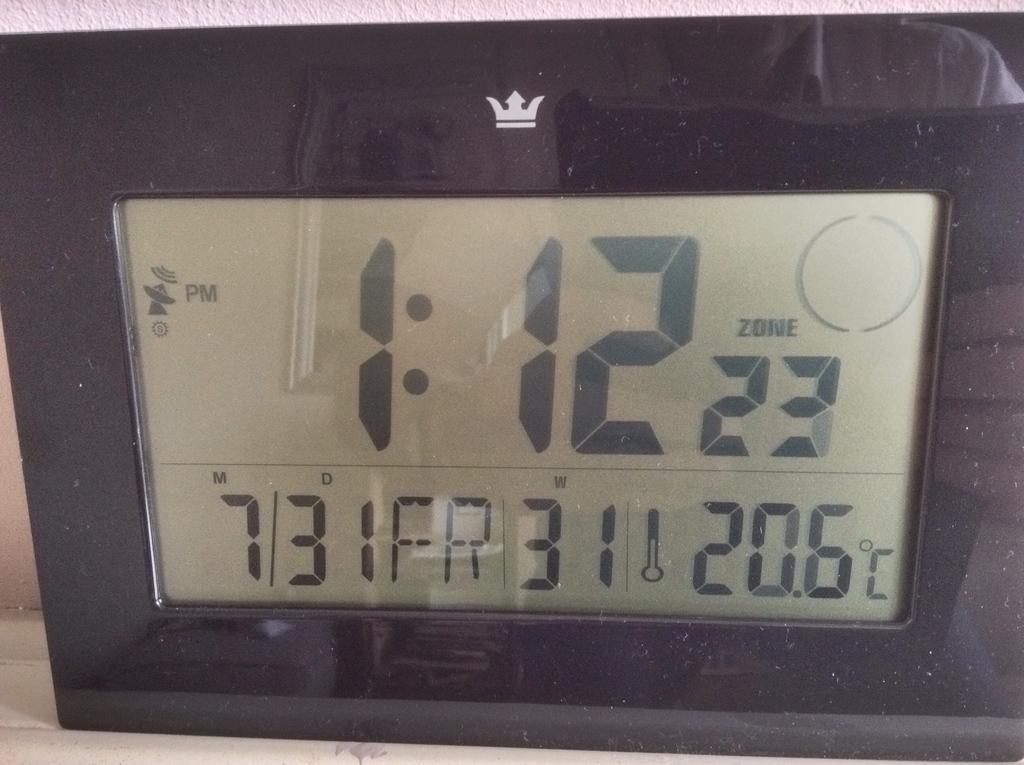What day of the week is it?
Keep it short and to the point. Friday. What is the word above 23?
Your response must be concise. Zone. 